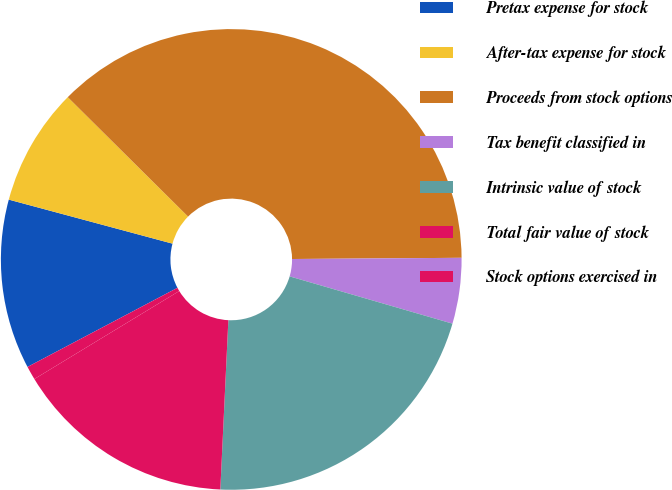<chart> <loc_0><loc_0><loc_500><loc_500><pie_chart><fcel>Pretax expense for stock<fcel>After-tax expense for stock<fcel>Proceeds from stock options<fcel>Tax benefit classified in<fcel>Intrinsic value of stock<fcel>Total fair value of stock<fcel>Stock options exercised in<nl><fcel>11.91%<fcel>8.26%<fcel>37.45%<fcel>4.61%<fcel>21.26%<fcel>15.56%<fcel>0.96%<nl></chart> 